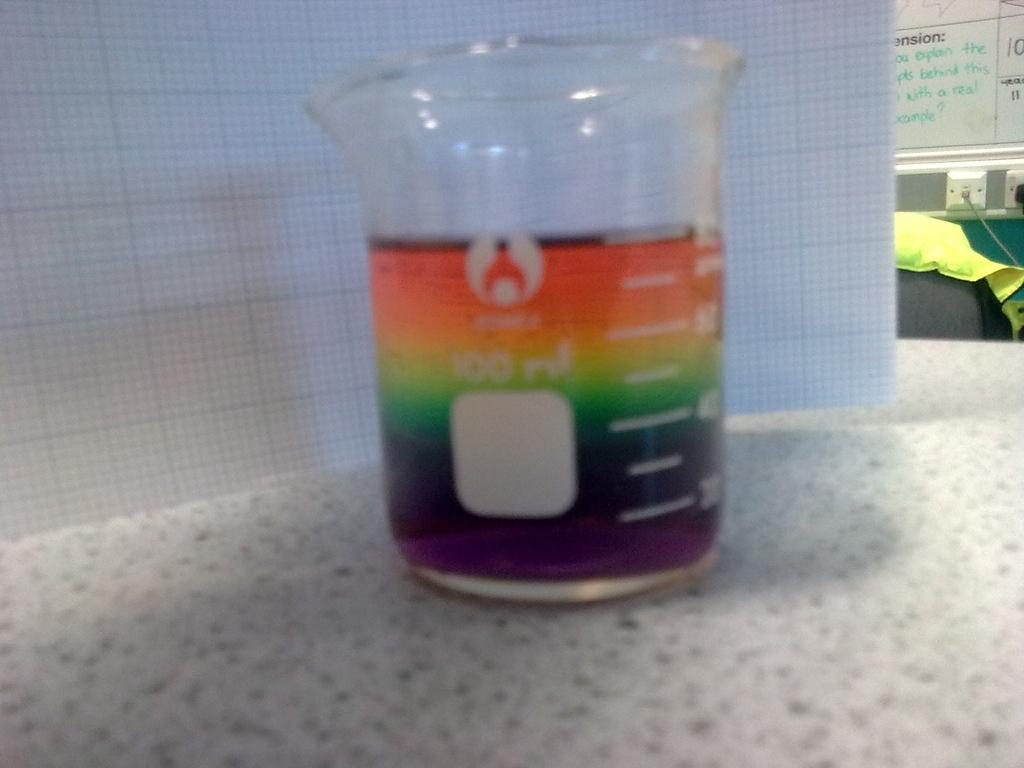Provide a one-sentence caption for the provided image. The measuring cup is marked where 100 ml is the maximum measurement. 